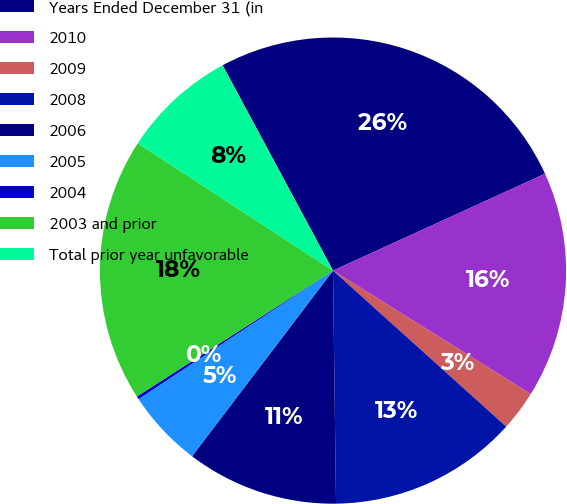Convert chart to OTSL. <chart><loc_0><loc_0><loc_500><loc_500><pie_chart><fcel>Years Ended December 31 (in<fcel>2010<fcel>2009<fcel>2008<fcel>2006<fcel>2005<fcel>2004<fcel>2003 and prior<fcel>Total prior year unfavorable<nl><fcel>26.03%<fcel>15.7%<fcel>2.79%<fcel>13.12%<fcel>10.54%<fcel>5.37%<fcel>0.21%<fcel>18.28%<fcel>7.95%<nl></chart> 